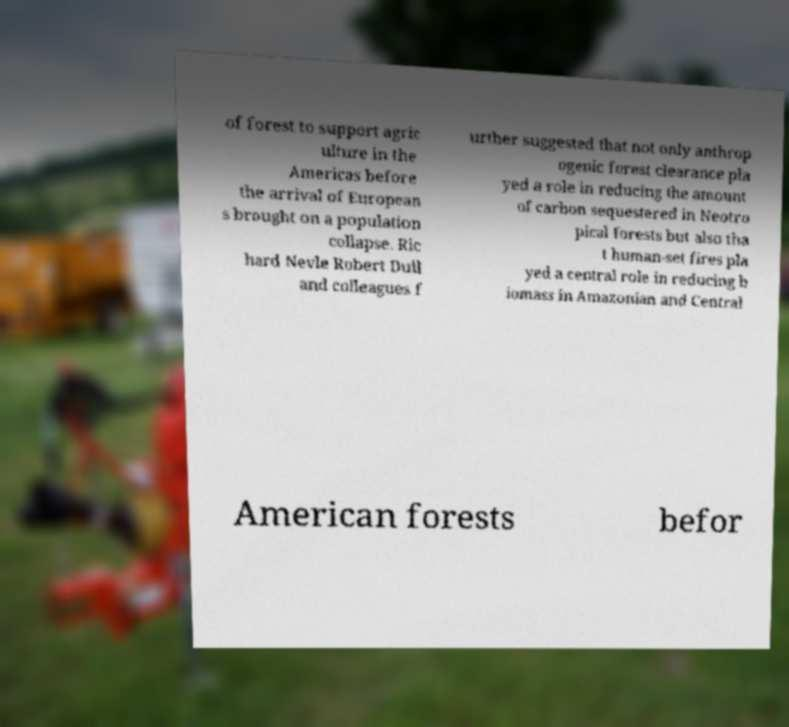Could you assist in decoding the text presented in this image and type it out clearly? of forest to support agric ulture in the Americas before the arrival of European s brought on a population collapse. Ric hard Nevle Robert Dull and colleagues f urther suggested that not only anthrop ogenic forest clearance pla yed a role in reducing the amount of carbon sequestered in Neotro pical forests but also tha t human-set fires pla yed a central role in reducing b iomass in Amazonian and Central American forests befor 